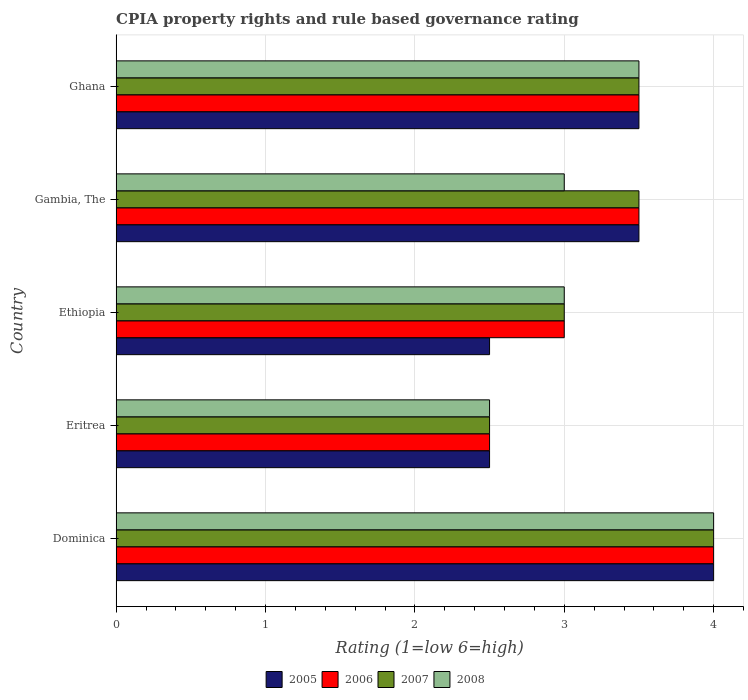How many groups of bars are there?
Offer a very short reply. 5. Are the number of bars per tick equal to the number of legend labels?
Make the answer very short. Yes. How many bars are there on the 4th tick from the top?
Your answer should be very brief. 4. How many bars are there on the 4th tick from the bottom?
Ensure brevity in your answer.  4. What is the label of the 3rd group of bars from the top?
Offer a terse response. Ethiopia. Across all countries, what is the maximum CPIA rating in 2006?
Your answer should be compact. 4. In which country was the CPIA rating in 2005 maximum?
Provide a short and direct response. Dominica. In which country was the CPIA rating in 2008 minimum?
Offer a terse response. Eritrea. What is the difference between the CPIA rating in 2006 in Eritrea and the CPIA rating in 2007 in Gambia, The?
Offer a very short reply. -1. What is the average CPIA rating in 2008 per country?
Make the answer very short. 3.2. In how many countries, is the CPIA rating in 2007 greater than 0.8 ?
Make the answer very short. 5. In how many countries, is the CPIA rating in 2005 greater than the average CPIA rating in 2005 taken over all countries?
Offer a very short reply. 3. Is the sum of the CPIA rating in 2007 in Dominica and Ethiopia greater than the maximum CPIA rating in 2005 across all countries?
Your answer should be very brief. Yes. Is it the case that in every country, the sum of the CPIA rating in 2006 and CPIA rating in 2008 is greater than the sum of CPIA rating in 2007 and CPIA rating in 2005?
Your answer should be very brief. No. Is it the case that in every country, the sum of the CPIA rating in 2006 and CPIA rating in 2008 is greater than the CPIA rating in 2007?
Give a very brief answer. Yes. Are the values on the major ticks of X-axis written in scientific E-notation?
Ensure brevity in your answer.  No. Does the graph contain grids?
Give a very brief answer. Yes. Where does the legend appear in the graph?
Give a very brief answer. Bottom center. How are the legend labels stacked?
Provide a short and direct response. Horizontal. What is the title of the graph?
Offer a terse response. CPIA property rights and rule based governance rating. What is the label or title of the X-axis?
Offer a very short reply. Rating (1=low 6=high). What is the Rating (1=low 6=high) in 2006 in Dominica?
Offer a terse response. 4. What is the Rating (1=low 6=high) of 2008 in Dominica?
Provide a short and direct response. 4. What is the Rating (1=low 6=high) of 2007 in Eritrea?
Ensure brevity in your answer.  2.5. What is the Rating (1=low 6=high) in 2008 in Eritrea?
Your answer should be very brief. 2.5. What is the Rating (1=low 6=high) in 2005 in Ethiopia?
Your answer should be compact. 2.5. What is the Rating (1=low 6=high) of 2006 in Ethiopia?
Make the answer very short. 3. What is the Rating (1=low 6=high) in 2007 in Ethiopia?
Keep it short and to the point. 3. What is the Rating (1=low 6=high) in 2005 in Gambia, The?
Keep it short and to the point. 3.5. What is the Rating (1=low 6=high) in 2006 in Ghana?
Provide a succinct answer. 3.5. Across all countries, what is the maximum Rating (1=low 6=high) in 2005?
Keep it short and to the point. 4. Across all countries, what is the minimum Rating (1=low 6=high) of 2006?
Your response must be concise. 2.5. What is the total Rating (1=low 6=high) of 2005 in the graph?
Provide a short and direct response. 16. What is the total Rating (1=low 6=high) in 2006 in the graph?
Offer a terse response. 16.5. What is the total Rating (1=low 6=high) of 2007 in the graph?
Keep it short and to the point. 16.5. What is the total Rating (1=low 6=high) in 2008 in the graph?
Provide a short and direct response. 16. What is the difference between the Rating (1=low 6=high) of 2006 in Dominica and that in Eritrea?
Provide a short and direct response. 1.5. What is the difference between the Rating (1=low 6=high) in 2007 in Dominica and that in Eritrea?
Provide a succinct answer. 1.5. What is the difference between the Rating (1=low 6=high) in 2007 in Dominica and that in Ethiopia?
Your response must be concise. 1. What is the difference between the Rating (1=low 6=high) of 2008 in Dominica and that in Ethiopia?
Keep it short and to the point. 1. What is the difference between the Rating (1=low 6=high) of 2005 in Dominica and that in Gambia, The?
Make the answer very short. 0.5. What is the difference between the Rating (1=low 6=high) of 2006 in Dominica and that in Gambia, The?
Provide a succinct answer. 0.5. What is the difference between the Rating (1=low 6=high) in 2007 in Dominica and that in Ghana?
Your answer should be very brief. 0.5. What is the difference between the Rating (1=low 6=high) of 2008 in Dominica and that in Ghana?
Provide a succinct answer. 0.5. What is the difference between the Rating (1=low 6=high) of 2006 in Eritrea and that in Ethiopia?
Offer a very short reply. -0.5. What is the difference between the Rating (1=low 6=high) of 2008 in Eritrea and that in Ethiopia?
Give a very brief answer. -0.5. What is the difference between the Rating (1=low 6=high) in 2006 in Eritrea and that in Gambia, The?
Make the answer very short. -1. What is the difference between the Rating (1=low 6=high) in 2005 in Eritrea and that in Ghana?
Keep it short and to the point. -1. What is the difference between the Rating (1=low 6=high) of 2007 in Eritrea and that in Ghana?
Ensure brevity in your answer.  -1. What is the difference between the Rating (1=low 6=high) in 2005 in Ethiopia and that in Gambia, The?
Your response must be concise. -1. What is the difference between the Rating (1=low 6=high) of 2007 in Ethiopia and that in Gambia, The?
Your answer should be compact. -0.5. What is the difference between the Rating (1=low 6=high) in 2006 in Ethiopia and that in Ghana?
Offer a terse response. -0.5. What is the difference between the Rating (1=low 6=high) in 2008 in Ethiopia and that in Ghana?
Make the answer very short. -0.5. What is the difference between the Rating (1=low 6=high) in 2006 in Gambia, The and that in Ghana?
Provide a succinct answer. 0. What is the difference between the Rating (1=low 6=high) of 2007 in Gambia, The and that in Ghana?
Ensure brevity in your answer.  0. What is the difference between the Rating (1=low 6=high) of 2005 in Dominica and the Rating (1=low 6=high) of 2006 in Eritrea?
Keep it short and to the point. 1.5. What is the difference between the Rating (1=low 6=high) of 2006 in Dominica and the Rating (1=low 6=high) of 2007 in Eritrea?
Provide a succinct answer. 1.5. What is the difference between the Rating (1=low 6=high) of 2006 in Dominica and the Rating (1=low 6=high) of 2008 in Eritrea?
Provide a short and direct response. 1.5. What is the difference between the Rating (1=low 6=high) in 2005 in Dominica and the Rating (1=low 6=high) in 2006 in Ethiopia?
Your answer should be compact. 1. What is the difference between the Rating (1=low 6=high) in 2005 in Dominica and the Rating (1=low 6=high) in 2007 in Ethiopia?
Ensure brevity in your answer.  1. What is the difference between the Rating (1=low 6=high) in 2006 in Dominica and the Rating (1=low 6=high) in 2007 in Ethiopia?
Provide a succinct answer. 1. What is the difference between the Rating (1=low 6=high) of 2006 in Dominica and the Rating (1=low 6=high) of 2008 in Ethiopia?
Keep it short and to the point. 1. What is the difference between the Rating (1=low 6=high) in 2005 in Dominica and the Rating (1=low 6=high) in 2006 in Gambia, The?
Your response must be concise. 0.5. What is the difference between the Rating (1=low 6=high) in 2005 in Dominica and the Rating (1=low 6=high) in 2008 in Gambia, The?
Give a very brief answer. 1. What is the difference between the Rating (1=low 6=high) in 2006 in Dominica and the Rating (1=low 6=high) in 2007 in Gambia, The?
Give a very brief answer. 0.5. What is the difference between the Rating (1=low 6=high) in 2006 in Dominica and the Rating (1=low 6=high) in 2008 in Gambia, The?
Make the answer very short. 1. What is the difference between the Rating (1=low 6=high) of 2005 in Dominica and the Rating (1=low 6=high) of 2007 in Ghana?
Ensure brevity in your answer.  0.5. What is the difference between the Rating (1=low 6=high) in 2005 in Dominica and the Rating (1=low 6=high) in 2008 in Ghana?
Your answer should be compact. 0.5. What is the difference between the Rating (1=low 6=high) in 2006 in Dominica and the Rating (1=low 6=high) in 2008 in Ghana?
Offer a terse response. 0.5. What is the difference between the Rating (1=low 6=high) of 2005 in Eritrea and the Rating (1=low 6=high) of 2006 in Ethiopia?
Provide a short and direct response. -0.5. What is the difference between the Rating (1=low 6=high) in 2005 in Eritrea and the Rating (1=low 6=high) in 2007 in Ethiopia?
Offer a very short reply. -0.5. What is the difference between the Rating (1=low 6=high) of 2006 in Eritrea and the Rating (1=low 6=high) of 2007 in Ethiopia?
Keep it short and to the point. -0.5. What is the difference between the Rating (1=low 6=high) in 2006 in Eritrea and the Rating (1=low 6=high) in 2008 in Ethiopia?
Provide a short and direct response. -0.5. What is the difference between the Rating (1=low 6=high) of 2005 in Eritrea and the Rating (1=low 6=high) of 2006 in Gambia, The?
Make the answer very short. -1. What is the difference between the Rating (1=low 6=high) in 2005 in Eritrea and the Rating (1=low 6=high) in 2007 in Gambia, The?
Offer a very short reply. -1. What is the difference between the Rating (1=low 6=high) of 2005 in Eritrea and the Rating (1=low 6=high) of 2008 in Gambia, The?
Offer a very short reply. -0.5. What is the difference between the Rating (1=low 6=high) in 2006 in Eritrea and the Rating (1=low 6=high) in 2008 in Gambia, The?
Ensure brevity in your answer.  -0.5. What is the difference between the Rating (1=low 6=high) of 2005 in Eritrea and the Rating (1=low 6=high) of 2006 in Ghana?
Your answer should be compact. -1. What is the difference between the Rating (1=low 6=high) in 2005 in Eritrea and the Rating (1=low 6=high) in 2007 in Ghana?
Make the answer very short. -1. What is the difference between the Rating (1=low 6=high) in 2006 in Eritrea and the Rating (1=low 6=high) in 2007 in Ghana?
Offer a terse response. -1. What is the difference between the Rating (1=low 6=high) in 2006 in Eritrea and the Rating (1=low 6=high) in 2008 in Ghana?
Your answer should be compact. -1. What is the difference between the Rating (1=low 6=high) in 2006 in Ethiopia and the Rating (1=low 6=high) in 2008 in Gambia, The?
Provide a short and direct response. 0. What is the difference between the Rating (1=low 6=high) of 2007 in Ethiopia and the Rating (1=low 6=high) of 2008 in Gambia, The?
Your answer should be very brief. 0. What is the difference between the Rating (1=low 6=high) in 2005 in Ethiopia and the Rating (1=low 6=high) in 2007 in Ghana?
Offer a terse response. -1. What is the difference between the Rating (1=low 6=high) in 2007 in Ethiopia and the Rating (1=low 6=high) in 2008 in Ghana?
Offer a very short reply. -0.5. What is the difference between the Rating (1=low 6=high) in 2005 in Gambia, The and the Rating (1=low 6=high) in 2006 in Ghana?
Offer a terse response. 0. What is the difference between the Rating (1=low 6=high) in 2005 in Gambia, The and the Rating (1=low 6=high) in 2007 in Ghana?
Offer a terse response. 0. What is the difference between the Rating (1=low 6=high) in 2007 in Gambia, The and the Rating (1=low 6=high) in 2008 in Ghana?
Your response must be concise. 0. What is the average Rating (1=low 6=high) of 2005 per country?
Keep it short and to the point. 3.2. What is the average Rating (1=low 6=high) in 2007 per country?
Give a very brief answer. 3.3. What is the average Rating (1=low 6=high) in 2008 per country?
Provide a succinct answer. 3.2. What is the difference between the Rating (1=low 6=high) of 2005 and Rating (1=low 6=high) of 2007 in Dominica?
Make the answer very short. 0. What is the difference between the Rating (1=low 6=high) of 2005 and Rating (1=low 6=high) of 2008 in Dominica?
Provide a succinct answer. 0. What is the difference between the Rating (1=low 6=high) of 2005 and Rating (1=low 6=high) of 2008 in Eritrea?
Ensure brevity in your answer.  0. What is the difference between the Rating (1=low 6=high) in 2005 and Rating (1=low 6=high) in 2007 in Ethiopia?
Your response must be concise. -0.5. What is the difference between the Rating (1=low 6=high) of 2005 and Rating (1=low 6=high) of 2006 in Gambia, The?
Offer a terse response. 0. What is the difference between the Rating (1=low 6=high) in 2006 and Rating (1=low 6=high) in 2007 in Gambia, The?
Offer a very short reply. 0. What is the difference between the Rating (1=low 6=high) in 2006 and Rating (1=low 6=high) in 2008 in Gambia, The?
Keep it short and to the point. 0.5. What is the difference between the Rating (1=low 6=high) of 2007 and Rating (1=low 6=high) of 2008 in Gambia, The?
Your answer should be very brief. 0.5. What is the difference between the Rating (1=low 6=high) of 2005 and Rating (1=low 6=high) of 2006 in Ghana?
Offer a very short reply. 0. What is the difference between the Rating (1=low 6=high) of 2005 and Rating (1=low 6=high) of 2008 in Ghana?
Your answer should be compact. 0. What is the difference between the Rating (1=low 6=high) in 2007 and Rating (1=low 6=high) in 2008 in Ghana?
Provide a short and direct response. 0. What is the ratio of the Rating (1=low 6=high) in 2007 in Dominica to that in Eritrea?
Your answer should be compact. 1.6. What is the ratio of the Rating (1=low 6=high) in 2006 in Dominica to that in Ethiopia?
Ensure brevity in your answer.  1.33. What is the ratio of the Rating (1=low 6=high) in 2007 in Dominica to that in Ethiopia?
Offer a very short reply. 1.33. What is the ratio of the Rating (1=low 6=high) of 2008 in Dominica to that in Ethiopia?
Give a very brief answer. 1.33. What is the ratio of the Rating (1=low 6=high) of 2005 in Dominica to that in Gambia, The?
Your response must be concise. 1.14. What is the ratio of the Rating (1=low 6=high) of 2005 in Eritrea to that in Ethiopia?
Keep it short and to the point. 1. What is the ratio of the Rating (1=low 6=high) of 2007 in Eritrea to that in Ethiopia?
Your answer should be very brief. 0.83. What is the ratio of the Rating (1=low 6=high) in 2008 in Eritrea to that in Ethiopia?
Your answer should be compact. 0.83. What is the ratio of the Rating (1=low 6=high) of 2005 in Eritrea to that in Gambia, The?
Offer a terse response. 0.71. What is the ratio of the Rating (1=low 6=high) of 2007 in Eritrea to that in Gambia, The?
Ensure brevity in your answer.  0.71. What is the ratio of the Rating (1=low 6=high) of 2008 in Eritrea to that in Gambia, The?
Keep it short and to the point. 0.83. What is the ratio of the Rating (1=low 6=high) in 2005 in Eritrea to that in Ghana?
Offer a terse response. 0.71. What is the ratio of the Rating (1=low 6=high) in 2006 in Eritrea to that in Ghana?
Provide a short and direct response. 0.71. What is the ratio of the Rating (1=low 6=high) in 2007 in Eritrea to that in Ghana?
Provide a succinct answer. 0.71. What is the ratio of the Rating (1=low 6=high) of 2005 in Ethiopia to that in Gambia, The?
Offer a very short reply. 0.71. What is the ratio of the Rating (1=low 6=high) in 2006 in Ethiopia to that in Gambia, The?
Keep it short and to the point. 0.86. What is the ratio of the Rating (1=low 6=high) in 2007 in Ethiopia to that in Gambia, The?
Provide a succinct answer. 0.86. What is the ratio of the Rating (1=low 6=high) of 2008 in Ethiopia to that in Gambia, The?
Your answer should be compact. 1. What is the ratio of the Rating (1=low 6=high) of 2005 in Ethiopia to that in Ghana?
Give a very brief answer. 0.71. What is the ratio of the Rating (1=low 6=high) of 2007 in Gambia, The to that in Ghana?
Make the answer very short. 1. What is the difference between the highest and the second highest Rating (1=low 6=high) in 2005?
Provide a succinct answer. 0.5. What is the difference between the highest and the second highest Rating (1=low 6=high) of 2007?
Provide a succinct answer. 0.5. What is the difference between the highest and the lowest Rating (1=low 6=high) of 2005?
Provide a short and direct response. 1.5. What is the difference between the highest and the lowest Rating (1=low 6=high) of 2007?
Ensure brevity in your answer.  1.5. 